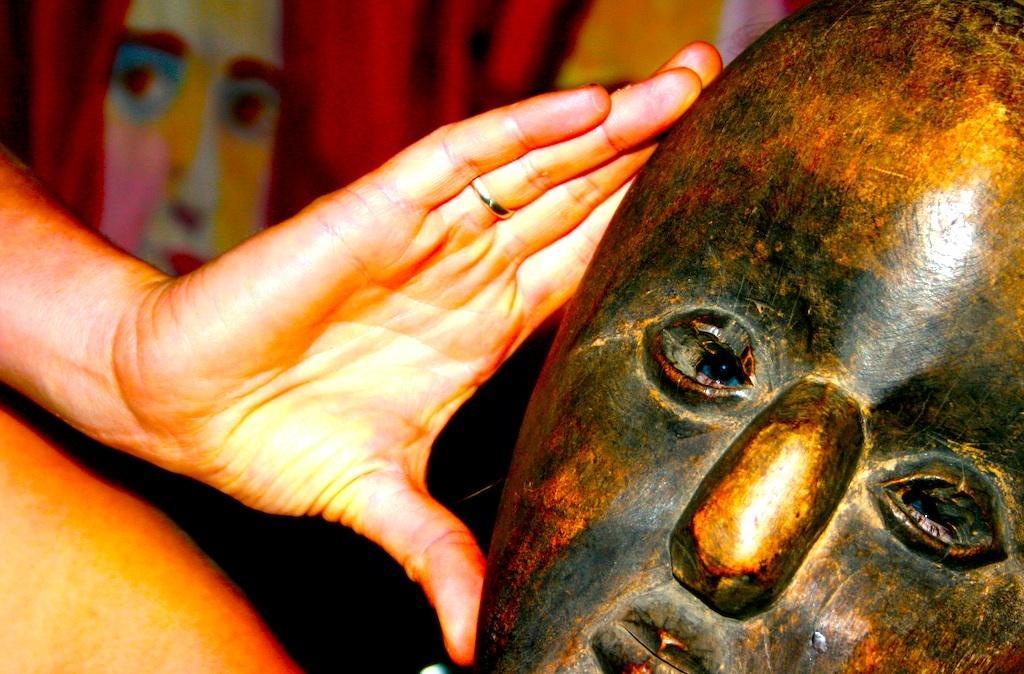Please provide a concise description of this image. In the right side a mask and in the left side it is a hand of a human. 